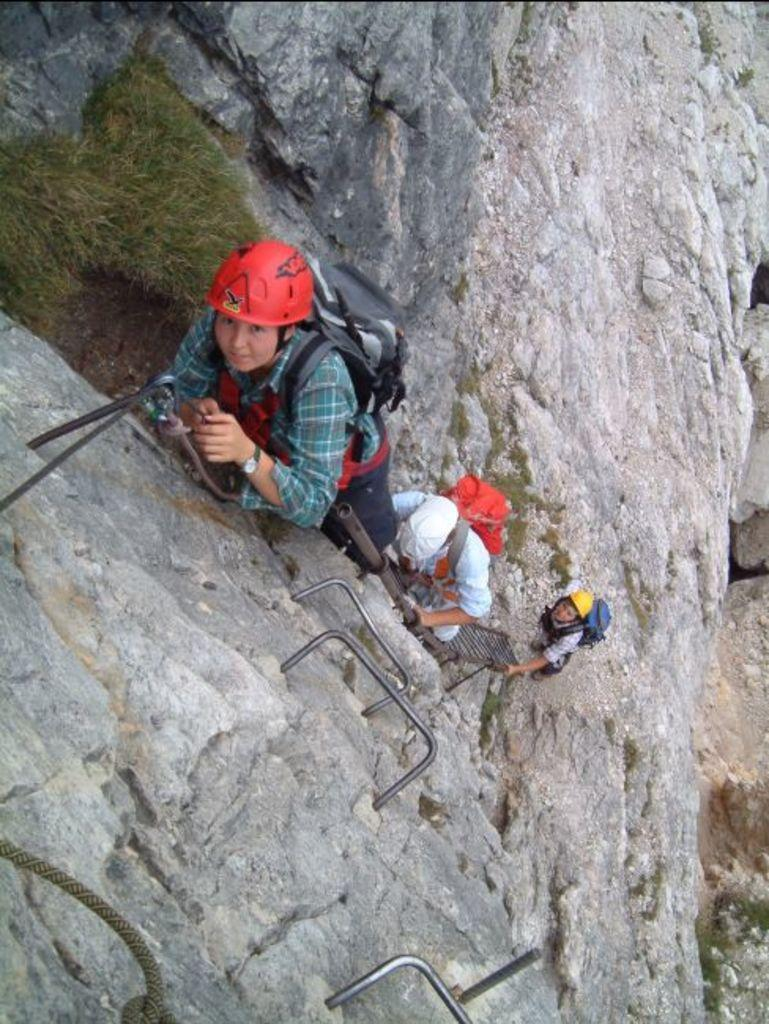What is happening in the image? There are people in the image, and they are climbing a hill. What is unique about the hill they are climbing? The hill has roads fixed on it. How are the people interacting with the roads while climbing? The people are holding the roads while climbing. What are the people wearing while climbing the hill? The people are wearing bags and helmets. What flavor of umbrella can be seen in the image? There is no umbrella present in the image, so it is not possible to determine the flavor of any umbrella. 